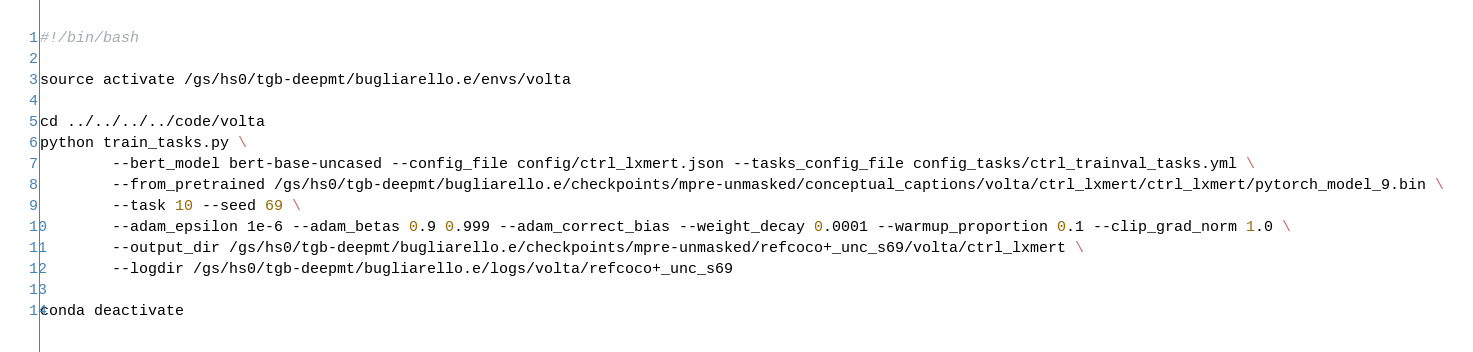Convert code to text. <code><loc_0><loc_0><loc_500><loc_500><_Bash_>#!/bin/bash

source activate /gs/hs0/tgb-deepmt/bugliarello.e/envs/volta

cd ../../../../code/volta
python train_tasks.py \
        --bert_model bert-base-uncased --config_file config/ctrl_lxmert.json --tasks_config_file config_tasks/ctrl_trainval_tasks.yml \
        --from_pretrained /gs/hs0/tgb-deepmt/bugliarello.e/checkpoints/mpre-unmasked/conceptual_captions/volta/ctrl_lxmert/ctrl_lxmert/pytorch_model_9.bin \
        --task 10 --seed 69 \
        --adam_epsilon 1e-6 --adam_betas 0.9 0.999 --adam_correct_bias --weight_decay 0.0001 --warmup_proportion 0.1 --clip_grad_norm 1.0 \
        --output_dir /gs/hs0/tgb-deepmt/bugliarello.e/checkpoints/mpre-unmasked/refcoco+_unc_s69/volta/ctrl_lxmert \
        --logdir /gs/hs0/tgb-deepmt/bugliarello.e/logs/volta/refcoco+_unc_s69

conda deactivate
</code> 